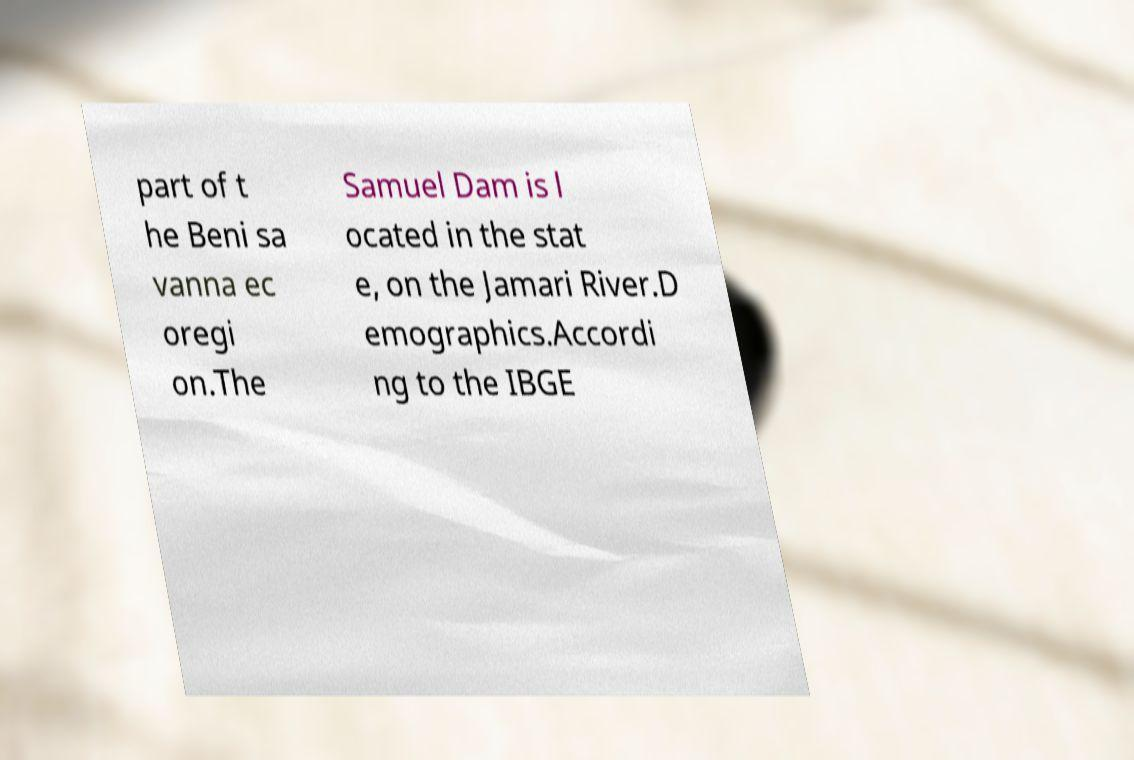Can you read and provide the text displayed in the image?This photo seems to have some interesting text. Can you extract and type it out for me? part of t he Beni sa vanna ec oregi on.The Samuel Dam is l ocated in the stat e, on the Jamari River.D emographics.Accordi ng to the IBGE 